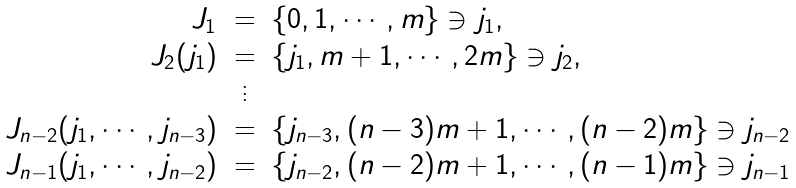Convert formula to latex. <formula><loc_0><loc_0><loc_500><loc_500>\begin{array} { r c l } J _ { 1 } & = & \{ 0 , 1 , \cdots , m \} \ni j _ { 1 } , \\ J _ { 2 } ( j _ { 1 } ) & = & \{ j _ { 1 } , m + 1 , \cdots , 2 m \} \ni j _ { 2 } , \\ & \vdots & \\ J _ { n - 2 } ( j _ { 1 } , \cdots , j _ { n - 3 } ) & = & \{ j _ { n - 3 } , ( n - 3 ) m + 1 , \cdots , ( n - 2 ) m \} \ni j _ { n - 2 } \\ J _ { n - 1 } ( j _ { 1 } , \cdots , j _ { n - 2 } ) & = & \{ j _ { n - 2 } , ( n - 2 ) m + 1 , \cdots , ( n - 1 ) m \} \ni j _ { n - 1 } \\ \end{array}</formula> 